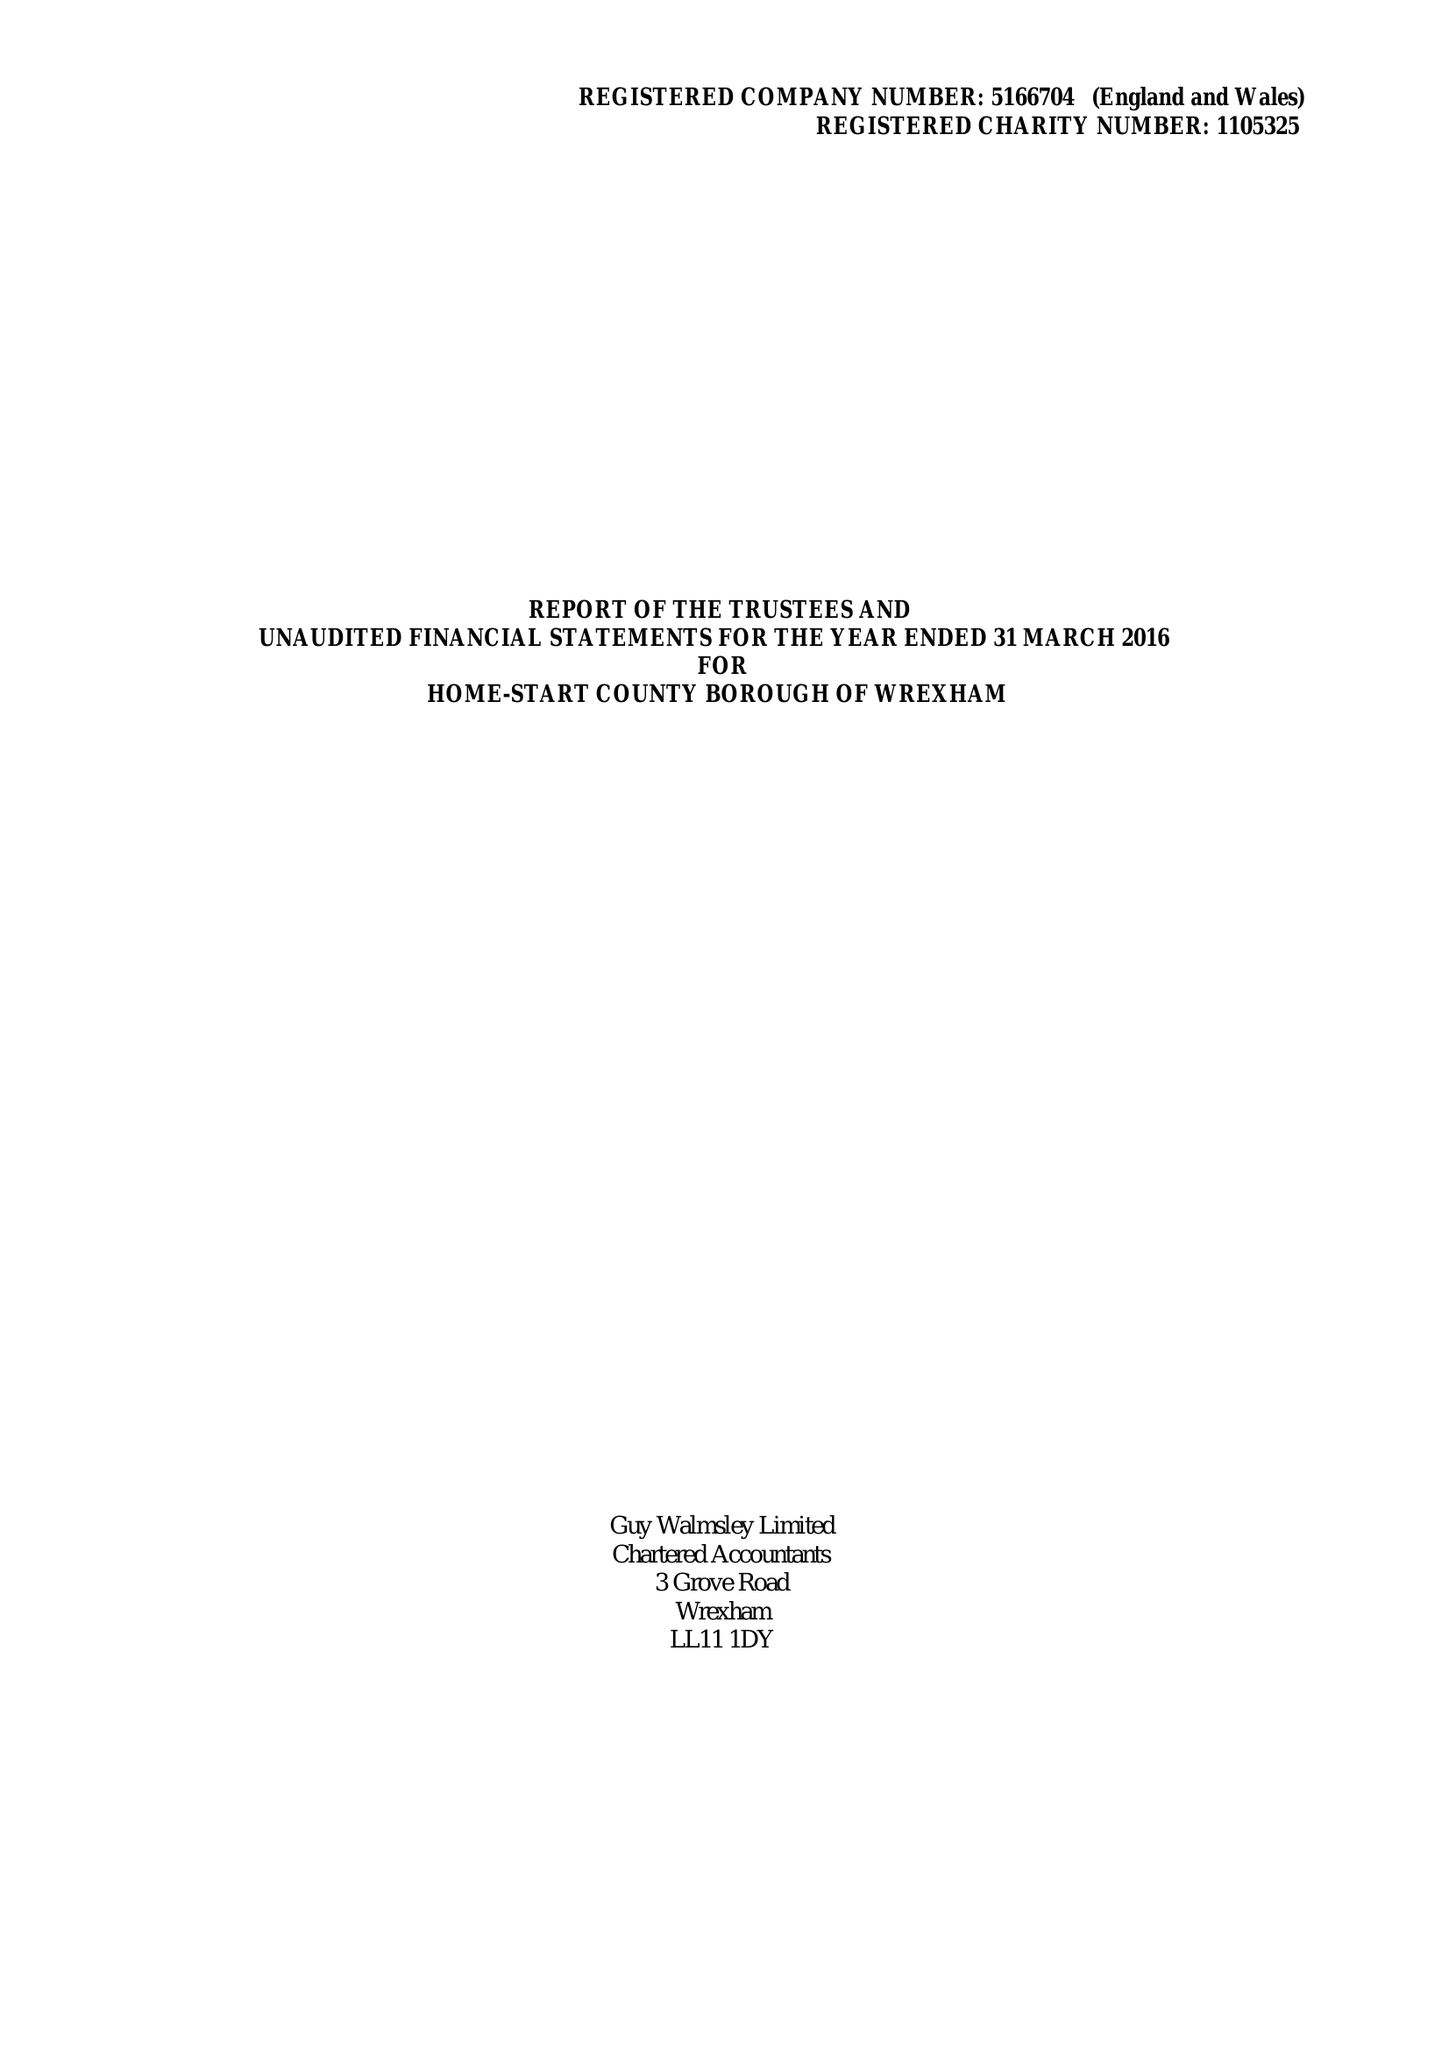What is the value for the spending_annually_in_british_pounds?
Answer the question using a single word or phrase. 153143.00 